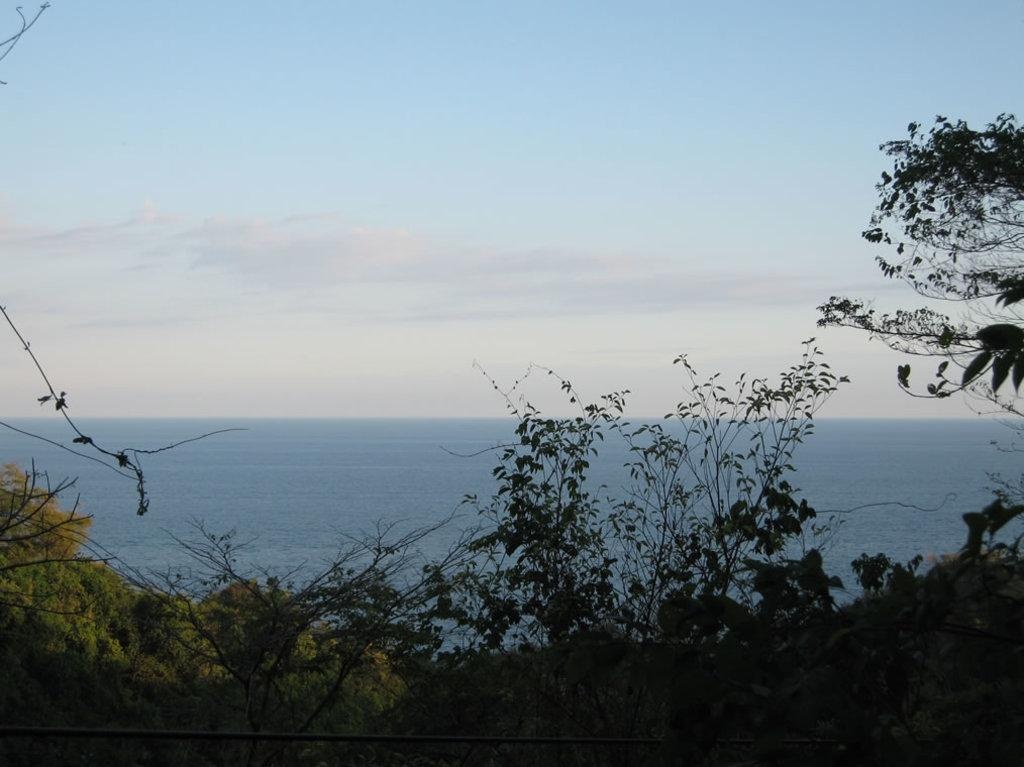What type of vegetation is in the foreground of the image? There are trees in the foreground of the image. What natural feature is located in the middle of the image? There is a water body in the middle of the image. What is visible at the top of the image? The sky is visible at the top of the image. What type of friction can be observed between the trees and the water body in the image? There is no friction between the trees and the water body in the image; the question is not relevant to the image's content. What nation is depicted in the image? The image does not depict any specific nation; it features natural elements such as trees, water, and sky. 